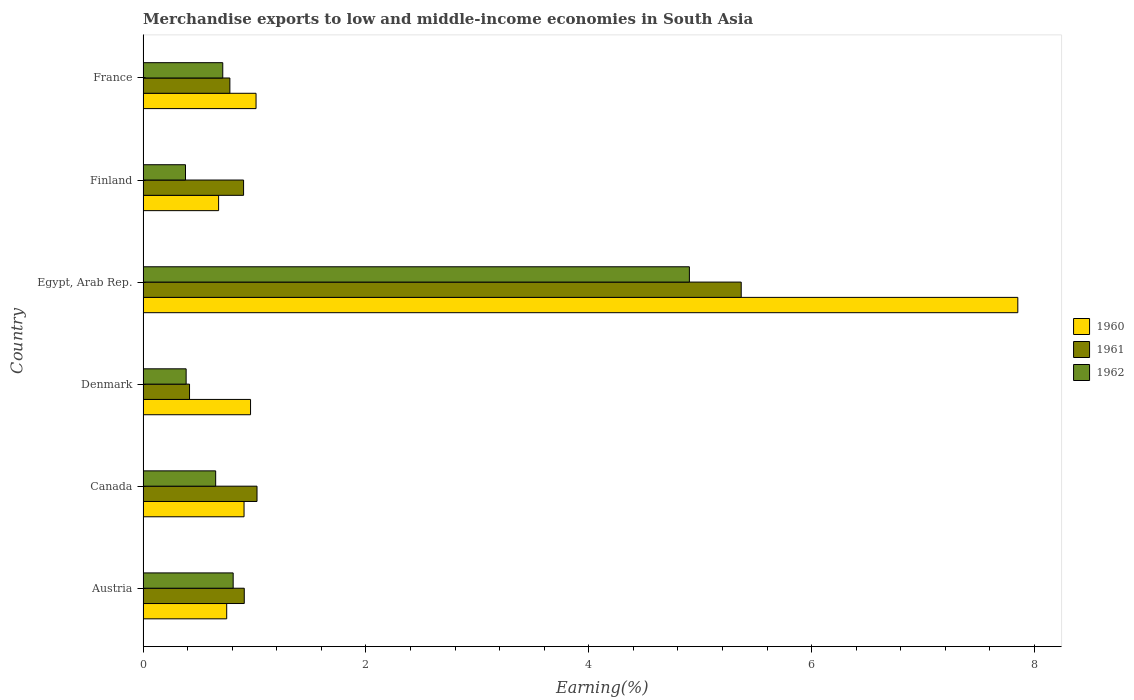How many different coloured bars are there?
Give a very brief answer. 3. Are the number of bars per tick equal to the number of legend labels?
Your answer should be compact. Yes. How many bars are there on the 5th tick from the top?
Give a very brief answer. 3. How many bars are there on the 3rd tick from the bottom?
Your answer should be very brief. 3. What is the label of the 3rd group of bars from the top?
Ensure brevity in your answer.  Egypt, Arab Rep. In how many cases, is the number of bars for a given country not equal to the number of legend labels?
Offer a very short reply. 0. What is the percentage of amount earned from merchandise exports in 1960 in Canada?
Offer a terse response. 0.91. Across all countries, what is the maximum percentage of amount earned from merchandise exports in 1961?
Make the answer very short. 5.37. Across all countries, what is the minimum percentage of amount earned from merchandise exports in 1960?
Keep it short and to the point. 0.68. In which country was the percentage of amount earned from merchandise exports in 1962 maximum?
Provide a short and direct response. Egypt, Arab Rep. In which country was the percentage of amount earned from merchandise exports in 1961 minimum?
Your response must be concise. Denmark. What is the total percentage of amount earned from merchandise exports in 1960 in the graph?
Provide a succinct answer. 12.17. What is the difference between the percentage of amount earned from merchandise exports in 1961 in Austria and that in Finland?
Your response must be concise. 0.01. What is the difference between the percentage of amount earned from merchandise exports in 1960 in France and the percentage of amount earned from merchandise exports in 1961 in Finland?
Offer a very short reply. 0.11. What is the average percentage of amount earned from merchandise exports in 1960 per country?
Offer a very short reply. 2.03. What is the difference between the percentage of amount earned from merchandise exports in 1962 and percentage of amount earned from merchandise exports in 1961 in Austria?
Your answer should be compact. -0.1. What is the ratio of the percentage of amount earned from merchandise exports in 1961 in Austria to that in Egypt, Arab Rep.?
Offer a terse response. 0.17. Is the difference between the percentage of amount earned from merchandise exports in 1962 in Austria and France greater than the difference between the percentage of amount earned from merchandise exports in 1961 in Austria and France?
Give a very brief answer. No. What is the difference between the highest and the second highest percentage of amount earned from merchandise exports in 1960?
Your response must be concise. 6.84. What is the difference between the highest and the lowest percentage of amount earned from merchandise exports in 1960?
Provide a succinct answer. 7.17. Is it the case that in every country, the sum of the percentage of amount earned from merchandise exports in 1960 and percentage of amount earned from merchandise exports in 1962 is greater than the percentage of amount earned from merchandise exports in 1961?
Make the answer very short. Yes. Does the graph contain any zero values?
Keep it short and to the point. No. Does the graph contain grids?
Your answer should be compact. No. Where does the legend appear in the graph?
Provide a short and direct response. Center right. How many legend labels are there?
Ensure brevity in your answer.  3. What is the title of the graph?
Your response must be concise. Merchandise exports to low and middle-income economies in South Asia. What is the label or title of the X-axis?
Make the answer very short. Earning(%). What is the Earning(%) of 1960 in Austria?
Make the answer very short. 0.75. What is the Earning(%) in 1961 in Austria?
Your answer should be compact. 0.91. What is the Earning(%) of 1962 in Austria?
Your answer should be very brief. 0.81. What is the Earning(%) in 1960 in Canada?
Keep it short and to the point. 0.91. What is the Earning(%) of 1961 in Canada?
Keep it short and to the point. 1.02. What is the Earning(%) of 1962 in Canada?
Your response must be concise. 0.65. What is the Earning(%) of 1960 in Denmark?
Provide a short and direct response. 0.96. What is the Earning(%) in 1961 in Denmark?
Your answer should be compact. 0.42. What is the Earning(%) in 1962 in Denmark?
Provide a short and direct response. 0.39. What is the Earning(%) of 1960 in Egypt, Arab Rep.?
Your answer should be very brief. 7.85. What is the Earning(%) of 1961 in Egypt, Arab Rep.?
Keep it short and to the point. 5.37. What is the Earning(%) of 1962 in Egypt, Arab Rep.?
Ensure brevity in your answer.  4.9. What is the Earning(%) of 1960 in Finland?
Ensure brevity in your answer.  0.68. What is the Earning(%) in 1961 in Finland?
Provide a succinct answer. 0.9. What is the Earning(%) of 1962 in Finland?
Provide a succinct answer. 0.38. What is the Earning(%) in 1960 in France?
Make the answer very short. 1.01. What is the Earning(%) of 1961 in France?
Give a very brief answer. 0.78. What is the Earning(%) of 1962 in France?
Make the answer very short. 0.72. Across all countries, what is the maximum Earning(%) of 1960?
Offer a terse response. 7.85. Across all countries, what is the maximum Earning(%) of 1961?
Ensure brevity in your answer.  5.37. Across all countries, what is the maximum Earning(%) in 1962?
Provide a succinct answer. 4.9. Across all countries, what is the minimum Earning(%) of 1960?
Ensure brevity in your answer.  0.68. Across all countries, what is the minimum Earning(%) in 1961?
Make the answer very short. 0.42. Across all countries, what is the minimum Earning(%) in 1962?
Offer a terse response. 0.38. What is the total Earning(%) of 1960 in the graph?
Keep it short and to the point. 12.16. What is the total Earning(%) in 1961 in the graph?
Provide a short and direct response. 9.4. What is the total Earning(%) of 1962 in the graph?
Keep it short and to the point. 7.85. What is the difference between the Earning(%) in 1960 in Austria and that in Canada?
Provide a succinct answer. -0.16. What is the difference between the Earning(%) of 1961 in Austria and that in Canada?
Give a very brief answer. -0.11. What is the difference between the Earning(%) of 1962 in Austria and that in Canada?
Offer a terse response. 0.16. What is the difference between the Earning(%) of 1960 in Austria and that in Denmark?
Your answer should be very brief. -0.21. What is the difference between the Earning(%) in 1961 in Austria and that in Denmark?
Make the answer very short. 0.49. What is the difference between the Earning(%) of 1962 in Austria and that in Denmark?
Offer a very short reply. 0.42. What is the difference between the Earning(%) of 1960 in Austria and that in Egypt, Arab Rep.?
Ensure brevity in your answer.  -7.1. What is the difference between the Earning(%) in 1961 in Austria and that in Egypt, Arab Rep.?
Ensure brevity in your answer.  -4.46. What is the difference between the Earning(%) in 1962 in Austria and that in Egypt, Arab Rep.?
Provide a succinct answer. -4.09. What is the difference between the Earning(%) in 1960 in Austria and that in Finland?
Ensure brevity in your answer.  0.07. What is the difference between the Earning(%) of 1961 in Austria and that in Finland?
Your answer should be compact. 0.01. What is the difference between the Earning(%) of 1962 in Austria and that in Finland?
Provide a short and direct response. 0.43. What is the difference between the Earning(%) of 1960 in Austria and that in France?
Your answer should be very brief. -0.26. What is the difference between the Earning(%) of 1961 in Austria and that in France?
Provide a succinct answer. 0.13. What is the difference between the Earning(%) of 1962 in Austria and that in France?
Offer a very short reply. 0.09. What is the difference between the Earning(%) in 1960 in Canada and that in Denmark?
Offer a terse response. -0.06. What is the difference between the Earning(%) in 1961 in Canada and that in Denmark?
Make the answer very short. 0.61. What is the difference between the Earning(%) of 1962 in Canada and that in Denmark?
Your response must be concise. 0.27. What is the difference between the Earning(%) in 1960 in Canada and that in Egypt, Arab Rep.?
Give a very brief answer. -6.94. What is the difference between the Earning(%) in 1961 in Canada and that in Egypt, Arab Rep.?
Give a very brief answer. -4.35. What is the difference between the Earning(%) in 1962 in Canada and that in Egypt, Arab Rep.?
Your response must be concise. -4.25. What is the difference between the Earning(%) of 1960 in Canada and that in Finland?
Your answer should be compact. 0.23. What is the difference between the Earning(%) of 1961 in Canada and that in Finland?
Keep it short and to the point. 0.12. What is the difference between the Earning(%) of 1962 in Canada and that in Finland?
Offer a very short reply. 0.27. What is the difference between the Earning(%) in 1960 in Canada and that in France?
Your answer should be compact. -0.11. What is the difference between the Earning(%) in 1961 in Canada and that in France?
Give a very brief answer. 0.24. What is the difference between the Earning(%) in 1962 in Canada and that in France?
Offer a very short reply. -0.06. What is the difference between the Earning(%) in 1960 in Denmark and that in Egypt, Arab Rep.?
Give a very brief answer. -6.89. What is the difference between the Earning(%) of 1961 in Denmark and that in Egypt, Arab Rep.?
Provide a succinct answer. -4.95. What is the difference between the Earning(%) of 1962 in Denmark and that in Egypt, Arab Rep.?
Your answer should be compact. -4.52. What is the difference between the Earning(%) in 1960 in Denmark and that in Finland?
Make the answer very short. 0.29. What is the difference between the Earning(%) of 1961 in Denmark and that in Finland?
Provide a short and direct response. -0.49. What is the difference between the Earning(%) of 1962 in Denmark and that in Finland?
Make the answer very short. 0.01. What is the difference between the Earning(%) of 1960 in Denmark and that in France?
Ensure brevity in your answer.  -0.05. What is the difference between the Earning(%) in 1961 in Denmark and that in France?
Offer a terse response. -0.36. What is the difference between the Earning(%) of 1962 in Denmark and that in France?
Provide a succinct answer. -0.33. What is the difference between the Earning(%) of 1960 in Egypt, Arab Rep. and that in Finland?
Offer a very short reply. 7.17. What is the difference between the Earning(%) of 1961 in Egypt, Arab Rep. and that in Finland?
Provide a short and direct response. 4.47. What is the difference between the Earning(%) in 1962 in Egypt, Arab Rep. and that in Finland?
Make the answer very short. 4.52. What is the difference between the Earning(%) of 1960 in Egypt, Arab Rep. and that in France?
Keep it short and to the point. 6.84. What is the difference between the Earning(%) in 1961 in Egypt, Arab Rep. and that in France?
Your answer should be very brief. 4.59. What is the difference between the Earning(%) in 1962 in Egypt, Arab Rep. and that in France?
Offer a very short reply. 4.19. What is the difference between the Earning(%) in 1960 in Finland and that in France?
Offer a very short reply. -0.34. What is the difference between the Earning(%) of 1961 in Finland and that in France?
Offer a terse response. 0.12. What is the difference between the Earning(%) in 1962 in Finland and that in France?
Give a very brief answer. -0.33. What is the difference between the Earning(%) of 1960 in Austria and the Earning(%) of 1961 in Canada?
Give a very brief answer. -0.27. What is the difference between the Earning(%) of 1960 in Austria and the Earning(%) of 1962 in Canada?
Your response must be concise. 0.1. What is the difference between the Earning(%) in 1961 in Austria and the Earning(%) in 1962 in Canada?
Provide a short and direct response. 0.26. What is the difference between the Earning(%) of 1960 in Austria and the Earning(%) of 1961 in Denmark?
Your response must be concise. 0.33. What is the difference between the Earning(%) of 1960 in Austria and the Earning(%) of 1962 in Denmark?
Offer a very short reply. 0.36. What is the difference between the Earning(%) of 1961 in Austria and the Earning(%) of 1962 in Denmark?
Ensure brevity in your answer.  0.52. What is the difference between the Earning(%) of 1960 in Austria and the Earning(%) of 1961 in Egypt, Arab Rep.?
Make the answer very short. -4.62. What is the difference between the Earning(%) in 1960 in Austria and the Earning(%) in 1962 in Egypt, Arab Rep.?
Your response must be concise. -4.15. What is the difference between the Earning(%) in 1961 in Austria and the Earning(%) in 1962 in Egypt, Arab Rep.?
Your answer should be very brief. -4. What is the difference between the Earning(%) in 1960 in Austria and the Earning(%) in 1961 in Finland?
Your response must be concise. -0.15. What is the difference between the Earning(%) in 1960 in Austria and the Earning(%) in 1962 in Finland?
Provide a succinct answer. 0.37. What is the difference between the Earning(%) in 1961 in Austria and the Earning(%) in 1962 in Finland?
Offer a terse response. 0.53. What is the difference between the Earning(%) of 1960 in Austria and the Earning(%) of 1961 in France?
Provide a succinct answer. -0.03. What is the difference between the Earning(%) in 1960 in Austria and the Earning(%) in 1962 in France?
Provide a succinct answer. 0.04. What is the difference between the Earning(%) in 1961 in Austria and the Earning(%) in 1962 in France?
Your response must be concise. 0.19. What is the difference between the Earning(%) of 1960 in Canada and the Earning(%) of 1961 in Denmark?
Ensure brevity in your answer.  0.49. What is the difference between the Earning(%) of 1960 in Canada and the Earning(%) of 1962 in Denmark?
Your response must be concise. 0.52. What is the difference between the Earning(%) in 1961 in Canada and the Earning(%) in 1962 in Denmark?
Your response must be concise. 0.64. What is the difference between the Earning(%) of 1960 in Canada and the Earning(%) of 1961 in Egypt, Arab Rep.?
Your answer should be compact. -4.46. What is the difference between the Earning(%) in 1960 in Canada and the Earning(%) in 1962 in Egypt, Arab Rep.?
Your answer should be compact. -4. What is the difference between the Earning(%) in 1961 in Canada and the Earning(%) in 1962 in Egypt, Arab Rep.?
Offer a terse response. -3.88. What is the difference between the Earning(%) in 1960 in Canada and the Earning(%) in 1961 in Finland?
Offer a very short reply. 0. What is the difference between the Earning(%) of 1960 in Canada and the Earning(%) of 1962 in Finland?
Offer a very short reply. 0.53. What is the difference between the Earning(%) of 1961 in Canada and the Earning(%) of 1962 in Finland?
Offer a very short reply. 0.64. What is the difference between the Earning(%) in 1960 in Canada and the Earning(%) in 1961 in France?
Offer a very short reply. 0.13. What is the difference between the Earning(%) in 1960 in Canada and the Earning(%) in 1962 in France?
Ensure brevity in your answer.  0.19. What is the difference between the Earning(%) of 1961 in Canada and the Earning(%) of 1962 in France?
Keep it short and to the point. 0.31. What is the difference between the Earning(%) of 1960 in Denmark and the Earning(%) of 1961 in Egypt, Arab Rep.?
Your answer should be very brief. -4.4. What is the difference between the Earning(%) of 1960 in Denmark and the Earning(%) of 1962 in Egypt, Arab Rep.?
Your answer should be compact. -3.94. What is the difference between the Earning(%) in 1961 in Denmark and the Earning(%) in 1962 in Egypt, Arab Rep.?
Your answer should be compact. -4.49. What is the difference between the Earning(%) in 1960 in Denmark and the Earning(%) in 1961 in Finland?
Ensure brevity in your answer.  0.06. What is the difference between the Earning(%) in 1960 in Denmark and the Earning(%) in 1962 in Finland?
Give a very brief answer. 0.58. What is the difference between the Earning(%) of 1961 in Denmark and the Earning(%) of 1962 in Finland?
Make the answer very short. 0.04. What is the difference between the Earning(%) of 1960 in Denmark and the Earning(%) of 1961 in France?
Ensure brevity in your answer.  0.19. What is the difference between the Earning(%) in 1960 in Denmark and the Earning(%) in 1962 in France?
Your response must be concise. 0.25. What is the difference between the Earning(%) in 1961 in Denmark and the Earning(%) in 1962 in France?
Make the answer very short. -0.3. What is the difference between the Earning(%) of 1960 in Egypt, Arab Rep. and the Earning(%) of 1961 in Finland?
Provide a short and direct response. 6.95. What is the difference between the Earning(%) of 1960 in Egypt, Arab Rep. and the Earning(%) of 1962 in Finland?
Give a very brief answer. 7.47. What is the difference between the Earning(%) in 1961 in Egypt, Arab Rep. and the Earning(%) in 1962 in Finland?
Your answer should be compact. 4.99. What is the difference between the Earning(%) of 1960 in Egypt, Arab Rep. and the Earning(%) of 1961 in France?
Offer a very short reply. 7.07. What is the difference between the Earning(%) of 1960 in Egypt, Arab Rep. and the Earning(%) of 1962 in France?
Your response must be concise. 7.14. What is the difference between the Earning(%) of 1961 in Egypt, Arab Rep. and the Earning(%) of 1962 in France?
Your response must be concise. 4.65. What is the difference between the Earning(%) in 1960 in Finland and the Earning(%) in 1961 in France?
Offer a very short reply. -0.1. What is the difference between the Earning(%) of 1960 in Finland and the Earning(%) of 1962 in France?
Offer a terse response. -0.04. What is the difference between the Earning(%) of 1961 in Finland and the Earning(%) of 1962 in France?
Provide a succinct answer. 0.19. What is the average Earning(%) of 1960 per country?
Keep it short and to the point. 2.03. What is the average Earning(%) of 1961 per country?
Provide a short and direct response. 1.57. What is the average Earning(%) of 1962 per country?
Ensure brevity in your answer.  1.31. What is the difference between the Earning(%) of 1960 and Earning(%) of 1961 in Austria?
Provide a succinct answer. -0.16. What is the difference between the Earning(%) of 1960 and Earning(%) of 1962 in Austria?
Keep it short and to the point. -0.06. What is the difference between the Earning(%) in 1961 and Earning(%) in 1962 in Austria?
Your answer should be compact. 0.1. What is the difference between the Earning(%) in 1960 and Earning(%) in 1961 in Canada?
Give a very brief answer. -0.12. What is the difference between the Earning(%) in 1960 and Earning(%) in 1962 in Canada?
Your answer should be very brief. 0.25. What is the difference between the Earning(%) of 1961 and Earning(%) of 1962 in Canada?
Provide a short and direct response. 0.37. What is the difference between the Earning(%) in 1960 and Earning(%) in 1961 in Denmark?
Offer a very short reply. 0.55. What is the difference between the Earning(%) in 1960 and Earning(%) in 1962 in Denmark?
Your answer should be compact. 0.58. What is the difference between the Earning(%) of 1961 and Earning(%) of 1962 in Denmark?
Provide a short and direct response. 0.03. What is the difference between the Earning(%) of 1960 and Earning(%) of 1961 in Egypt, Arab Rep.?
Your response must be concise. 2.48. What is the difference between the Earning(%) in 1960 and Earning(%) in 1962 in Egypt, Arab Rep.?
Your response must be concise. 2.95. What is the difference between the Earning(%) of 1961 and Earning(%) of 1962 in Egypt, Arab Rep.?
Make the answer very short. 0.47. What is the difference between the Earning(%) of 1960 and Earning(%) of 1961 in Finland?
Give a very brief answer. -0.22. What is the difference between the Earning(%) of 1960 and Earning(%) of 1962 in Finland?
Give a very brief answer. 0.3. What is the difference between the Earning(%) in 1961 and Earning(%) in 1962 in Finland?
Make the answer very short. 0.52. What is the difference between the Earning(%) of 1960 and Earning(%) of 1961 in France?
Offer a terse response. 0.23. What is the difference between the Earning(%) of 1960 and Earning(%) of 1962 in France?
Offer a very short reply. 0.3. What is the difference between the Earning(%) in 1961 and Earning(%) in 1962 in France?
Provide a short and direct response. 0.06. What is the ratio of the Earning(%) of 1960 in Austria to that in Canada?
Keep it short and to the point. 0.83. What is the ratio of the Earning(%) in 1961 in Austria to that in Canada?
Your answer should be very brief. 0.89. What is the ratio of the Earning(%) in 1962 in Austria to that in Canada?
Provide a short and direct response. 1.24. What is the ratio of the Earning(%) in 1960 in Austria to that in Denmark?
Your answer should be compact. 0.78. What is the ratio of the Earning(%) of 1961 in Austria to that in Denmark?
Your response must be concise. 2.18. What is the ratio of the Earning(%) in 1962 in Austria to that in Denmark?
Provide a succinct answer. 2.09. What is the ratio of the Earning(%) of 1960 in Austria to that in Egypt, Arab Rep.?
Give a very brief answer. 0.1. What is the ratio of the Earning(%) of 1961 in Austria to that in Egypt, Arab Rep.?
Your answer should be compact. 0.17. What is the ratio of the Earning(%) of 1962 in Austria to that in Egypt, Arab Rep.?
Ensure brevity in your answer.  0.16. What is the ratio of the Earning(%) of 1960 in Austria to that in Finland?
Give a very brief answer. 1.11. What is the ratio of the Earning(%) of 1961 in Austria to that in Finland?
Ensure brevity in your answer.  1.01. What is the ratio of the Earning(%) in 1962 in Austria to that in Finland?
Provide a succinct answer. 2.12. What is the ratio of the Earning(%) of 1960 in Austria to that in France?
Provide a short and direct response. 0.74. What is the ratio of the Earning(%) in 1961 in Austria to that in France?
Ensure brevity in your answer.  1.17. What is the ratio of the Earning(%) of 1962 in Austria to that in France?
Offer a very short reply. 1.13. What is the ratio of the Earning(%) in 1960 in Canada to that in Denmark?
Your answer should be compact. 0.94. What is the ratio of the Earning(%) in 1961 in Canada to that in Denmark?
Offer a terse response. 2.45. What is the ratio of the Earning(%) of 1962 in Canada to that in Denmark?
Your answer should be compact. 1.69. What is the ratio of the Earning(%) in 1960 in Canada to that in Egypt, Arab Rep.?
Your answer should be compact. 0.12. What is the ratio of the Earning(%) of 1961 in Canada to that in Egypt, Arab Rep.?
Provide a succinct answer. 0.19. What is the ratio of the Earning(%) of 1962 in Canada to that in Egypt, Arab Rep.?
Offer a terse response. 0.13. What is the ratio of the Earning(%) of 1960 in Canada to that in Finland?
Offer a terse response. 1.34. What is the ratio of the Earning(%) of 1961 in Canada to that in Finland?
Your answer should be compact. 1.13. What is the ratio of the Earning(%) in 1962 in Canada to that in Finland?
Offer a terse response. 1.71. What is the ratio of the Earning(%) in 1960 in Canada to that in France?
Your answer should be very brief. 0.89. What is the ratio of the Earning(%) in 1961 in Canada to that in France?
Provide a succinct answer. 1.31. What is the ratio of the Earning(%) in 1962 in Canada to that in France?
Your response must be concise. 0.91. What is the ratio of the Earning(%) in 1960 in Denmark to that in Egypt, Arab Rep.?
Make the answer very short. 0.12. What is the ratio of the Earning(%) in 1961 in Denmark to that in Egypt, Arab Rep.?
Keep it short and to the point. 0.08. What is the ratio of the Earning(%) in 1962 in Denmark to that in Egypt, Arab Rep.?
Keep it short and to the point. 0.08. What is the ratio of the Earning(%) in 1960 in Denmark to that in Finland?
Your response must be concise. 1.42. What is the ratio of the Earning(%) in 1961 in Denmark to that in Finland?
Provide a short and direct response. 0.46. What is the ratio of the Earning(%) in 1962 in Denmark to that in Finland?
Provide a short and direct response. 1.02. What is the ratio of the Earning(%) in 1960 in Denmark to that in France?
Offer a very short reply. 0.95. What is the ratio of the Earning(%) of 1961 in Denmark to that in France?
Your response must be concise. 0.54. What is the ratio of the Earning(%) of 1962 in Denmark to that in France?
Offer a terse response. 0.54. What is the ratio of the Earning(%) in 1960 in Egypt, Arab Rep. to that in Finland?
Offer a terse response. 11.58. What is the ratio of the Earning(%) in 1961 in Egypt, Arab Rep. to that in Finland?
Your answer should be very brief. 5.95. What is the ratio of the Earning(%) in 1962 in Egypt, Arab Rep. to that in Finland?
Keep it short and to the point. 12.88. What is the ratio of the Earning(%) of 1960 in Egypt, Arab Rep. to that in France?
Your response must be concise. 7.74. What is the ratio of the Earning(%) in 1961 in Egypt, Arab Rep. to that in France?
Provide a succinct answer. 6.89. What is the ratio of the Earning(%) of 1962 in Egypt, Arab Rep. to that in France?
Provide a short and direct response. 6.85. What is the ratio of the Earning(%) in 1960 in Finland to that in France?
Your answer should be compact. 0.67. What is the ratio of the Earning(%) of 1961 in Finland to that in France?
Make the answer very short. 1.16. What is the ratio of the Earning(%) in 1962 in Finland to that in France?
Make the answer very short. 0.53. What is the difference between the highest and the second highest Earning(%) in 1960?
Give a very brief answer. 6.84. What is the difference between the highest and the second highest Earning(%) in 1961?
Give a very brief answer. 4.35. What is the difference between the highest and the second highest Earning(%) of 1962?
Provide a succinct answer. 4.09. What is the difference between the highest and the lowest Earning(%) of 1960?
Provide a succinct answer. 7.17. What is the difference between the highest and the lowest Earning(%) in 1961?
Ensure brevity in your answer.  4.95. What is the difference between the highest and the lowest Earning(%) in 1962?
Give a very brief answer. 4.52. 